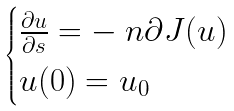Convert formula to latex. <formula><loc_0><loc_0><loc_500><loc_500>\begin{cases} \frac { \partial u } { \partial s } = - \ n \partial J ( u ) \\ u ( 0 ) = u _ { 0 } \end{cases}</formula> 